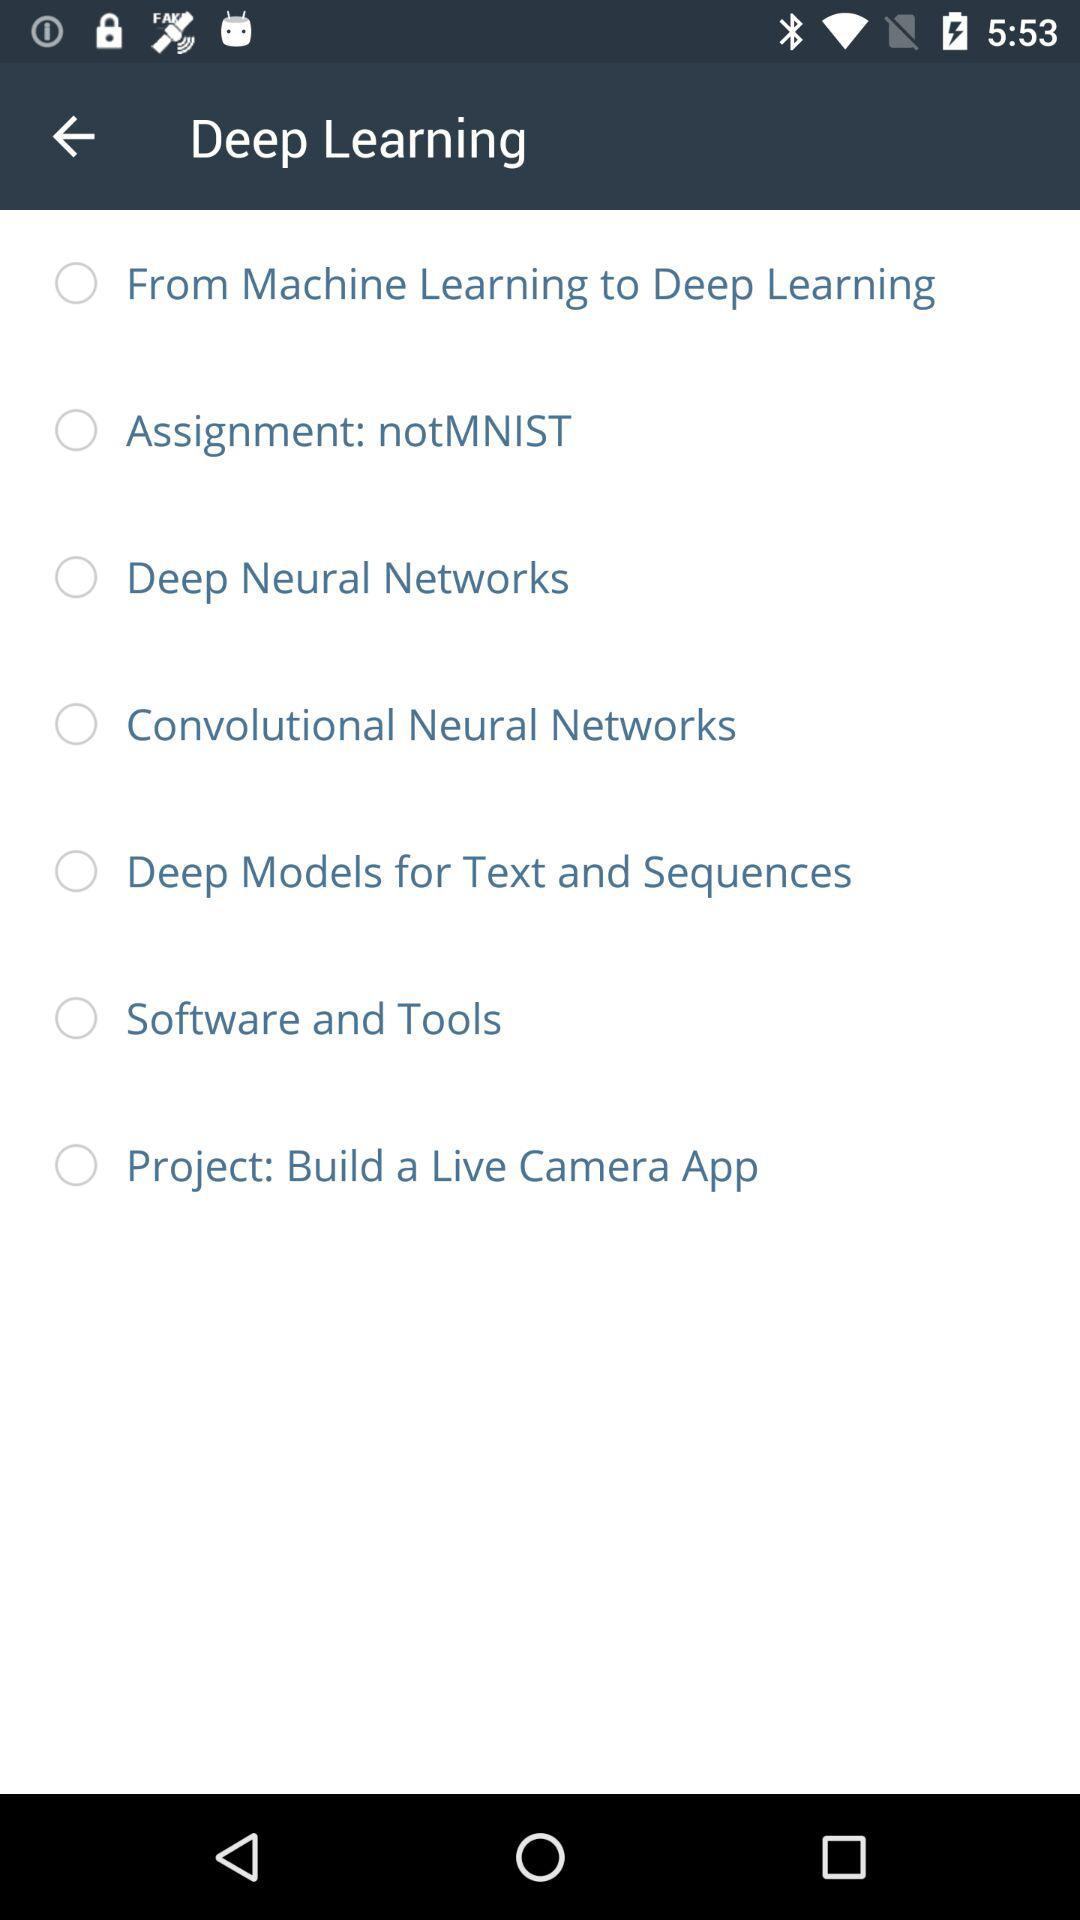How many lessons are in this course?
Answer the question using a single word or phrase. 7 